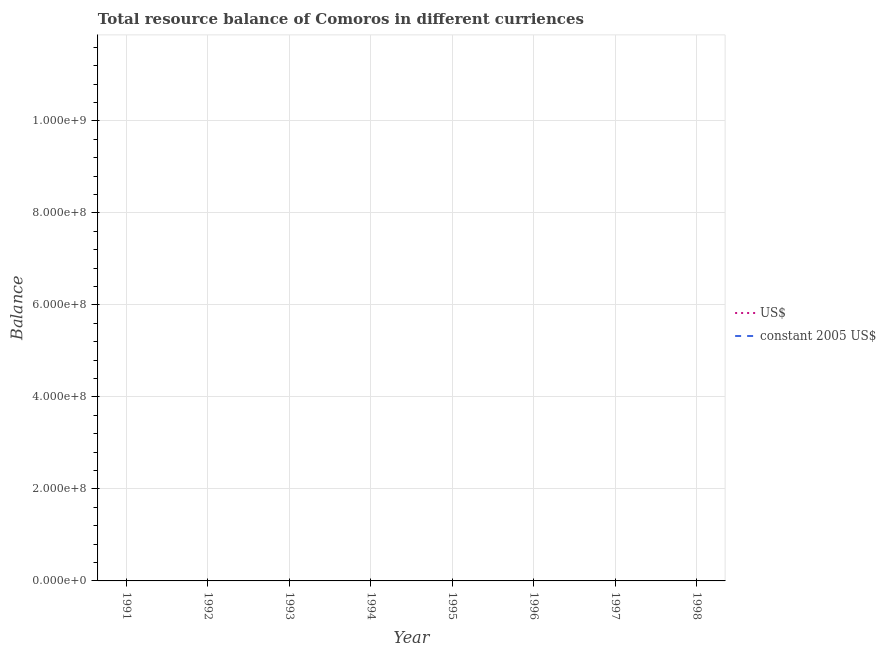How many different coloured lines are there?
Give a very brief answer. 0. Does the line corresponding to resource balance in constant us$ intersect with the line corresponding to resource balance in us$?
Provide a succinct answer. No. What is the resource balance in constant us$ in 1994?
Give a very brief answer. 0. Across all years, what is the minimum resource balance in constant us$?
Your answer should be very brief. 0. Is the resource balance in us$ strictly greater than the resource balance in constant us$ over the years?
Your answer should be compact. Yes. How many lines are there?
Make the answer very short. 0. How many years are there in the graph?
Provide a short and direct response. 8. Are the values on the major ticks of Y-axis written in scientific E-notation?
Make the answer very short. Yes. Does the graph contain any zero values?
Offer a terse response. Yes. Does the graph contain grids?
Provide a short and direct response. Yes. How are the legend labels stacked?
Give a very brief answer. Vertical. What is the title of the graph?
Provide a succinct answer. Total resource balance of Comoros in different curriences. What is the label or title of the Y-axis?
Your response must be concise. Balance. What is the Balance in constant 2005 US$ in 1991?
Give a very brief answer. 0. What is the Balance of US$ in 1992?
Your answer should be compact. 0. What is the Balance of constant 2005 US$ in 1992?
Provide a short and direct response. 0. What is the Balance in US$ in 1994?
Offer a very short reply. 0. What is the Balance of US$ in 1996?
Give a very brief answer. 0. What is the Balance of constant 2005 US$ in 1996?
Keep it short and to the point. 0. What is the Balance in US$ in 1998?
Ensure brevity in your answer.  0. What is the Balance of constant 2005 US$ in 1998?
Make the answer very short. 0. What is the average Balance of US$ per year?
Your answer should be very brief. 0. What is the average Balance in constant 2005 US$ per year?
Give a very brief answer. 0. 